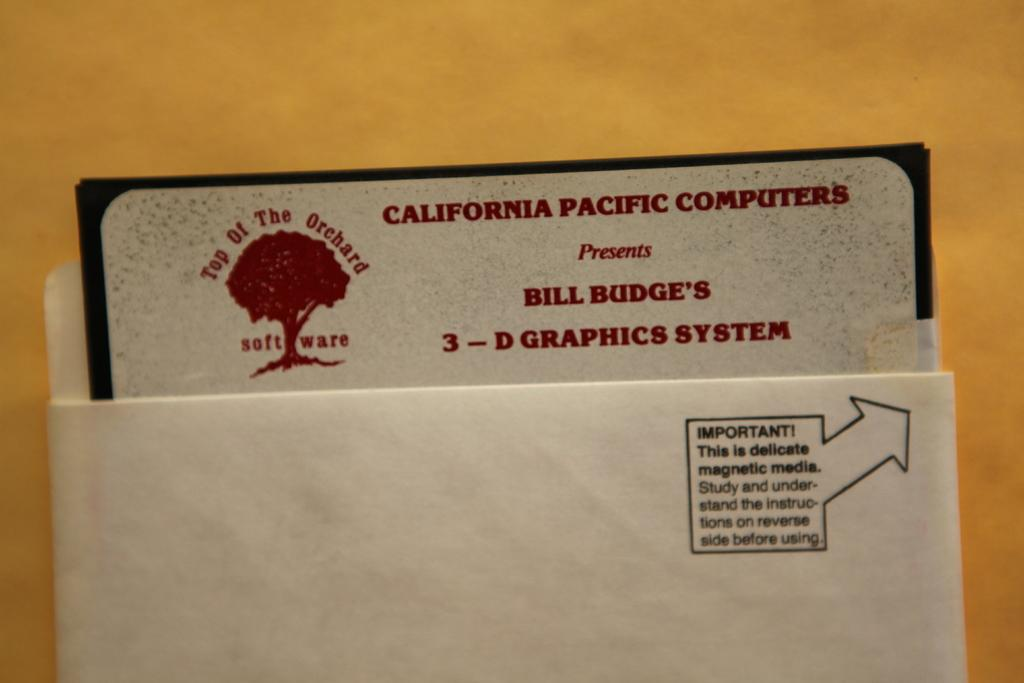<image>
Describe the image concisely. Bill Budge's 3-D Graphics System is inside a container. 